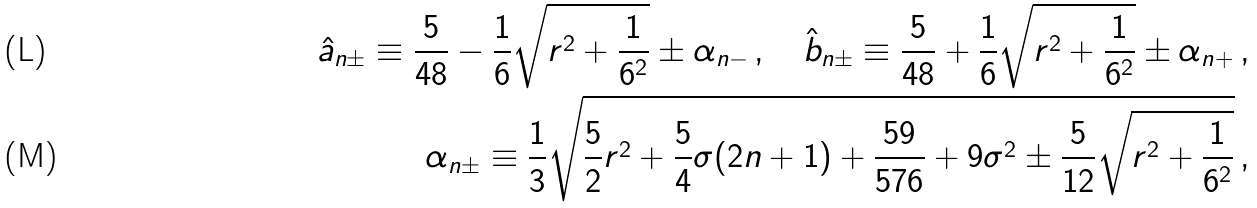Convert formula to latex. <formula><loc_0><loc_0><loc_500><loc_500>\hat { a } _ { n \pm } \equiv \frac { 5 } { 4 8 } - \frac { 1 } { 6 } \sqrt { r ^ { 2 } + \frac { 1 } { 6 ^ { 2 } } } \pm \alpha _ { n - } \, , \quad \hat { b } _ { n \pm } \equiv \frac { 5 } { 4 8 } + \frac { 1 } { 6 } \sqrt { r ^ { 2 } + \frac { 1 } { 6 ^ { 2 } } } \pm \alpha _ { n + } \, , \\ \alpha _ { n \pm } \equiv \frac { 1 } { 3 } \sqrt { \frac { 5 } { 2 } r ^ { 2 } + \frac { 5 } { 4 } \sigma ( 2 n + 1 ) + \frac { 5 9 } { 5 7 6 } + 9 \sigma ^ { 2 } \pm \frac { 5 } { 1 2 } \sqrt { r ^ { 2 } + \frac { 1 } { 6 ^ { 2 } } } } \, ,</formula> 